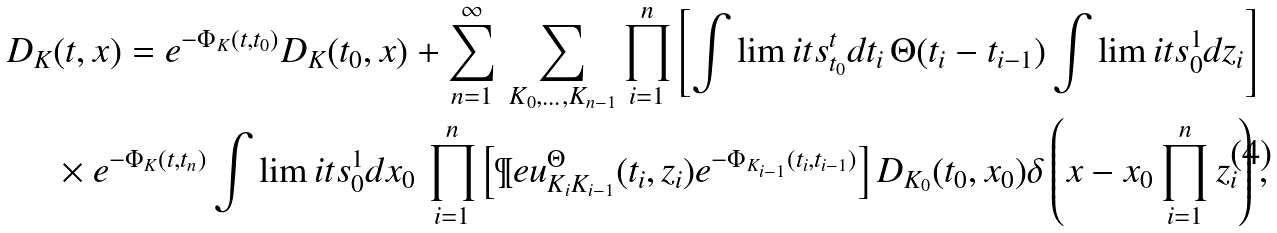<formula> <loc_0><loc_0><loc_500><loc_500>D _ { K } & ( t , x ) = e ^ { - \Phi _ { K } ( t , t _ { 0 } ) } D _ { K } ( t _ { 0 } , x ) + \sum _ { n = 1 } ^ { \infty } \, \sum _ { K _ { 0 } , \dots , K _ { n - 1 } } \prod _ { i = 1 } ^ { n } \left [ \int \lim i t s _ { t _ { 0 } } ^ { t } d t _ { i } \, \Theta ( t _ { i } - t _ { i - 1 } ) \int \lim i t s _ { 0 } ^ { 1 } d z _ { i } \right ] \\ & \times e ^ { - \Phi _ { K } ( t , t _ { n } ) } \int \lim i t s _ { 0 } ^ { 1 } d x _ { 0 } \, \prod _ { i = 1 } ^ { n } \left [ \P e u _ { K _ { i } K _ { i - 1 } } ^ { \Theta } ( t _ { i } , z _ { i } ) e ^ { - \Phi _ { K _ { i - 1 } } ( t _ { i } , t _ { i - 1 } ) } \right ] D _ { K _ { 0 } } ( t _ { 0 } , x _ { 0 } ) \delta \left ( x - x _ { 0 } \prod _ { i = 1 } ^ { n } z _ { i } \right ) ,</formula> 